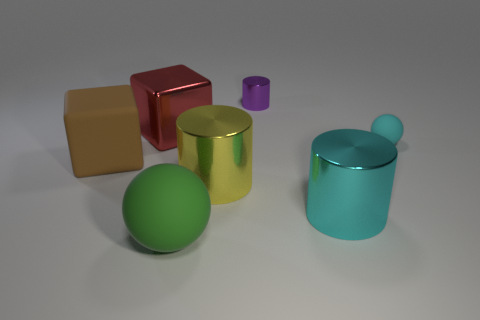What material is the small cyan object that is the same shape as the big green rubber thing?
Make the answer very short. Rubber. There is a ball that is behind the large rubber thing that is on the left side of the large green matte object; what is it made of?
Provide a succinct answer. Rubber. Are there the same number of small shiny things that are in front of the large red metal thing and tiny cyan matte spheres that are to the left of the small cyan rubber ball?
Keep it short and to the point. Yes. How many other things are the same color as the large rubber block?
Your answer should be compact. 0. There is a small sphere; is its color the same as the large cylinder that is right of the purple thing?
Give a very brief answer. Yes. What number of purple objects are either rubber blocks or large shiny blocks?
Provide a short and direct response. 0. Is the number of large yellow metal objects that are behind the metallic block the same as the number of large green metal objects?
Your response must be concise. Yes. There is a big object that is the same shape as the small cyan thing; what is its color?
Provide a succinct answer. Green. How many other small matte objects are the same shape as the brown rubber object?
Provide a succinct answer. 0. There is a big object that is the same color as the small matte object; what is it made of?
Make the answer very short. Metal. 